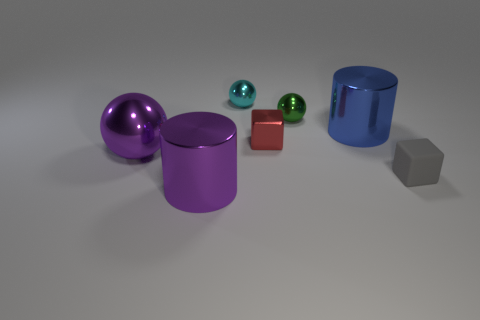Add 2 tiny shiny objects. How many objects exist? 9 Subtract all cubes. How many objects are left? 5 Add 6 balls. How many balls are left? 9 Add 5 small green metal things. How many small green metal things exist? 6 Subtract 1 blue cylinders. How many objects are left? 6 Subtract all red objects. Subtract all tiny things. How many objects are left? 2 